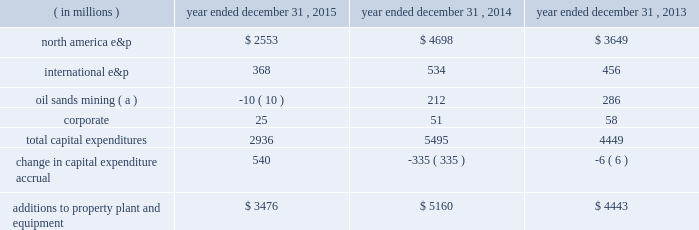Borrowings reflect net proceeds received from the issuance of senior notes in june 2015 .
See liquidity and capital resources below for additional information .
In november 2015 , we repaid our $ 1 billion 0.90% ( 0.90 % ) senior notes upon maturity .
In october 2015 , we announced an adjustment to our quarterly dividend .
See capital requirements below for additional information .
Additions to property , plant and equipment are our most significant use of cash and cash equivalents .
The table shows capital expenditures related to continuing operations by segment and reconciles to additions to property , plant and equipment as presented in the consolidated statements of cash flows for 2015 , 2014 and 2013: .
( a ) reflects reimbursements earned from the governments of canada and alberta related to funds previously expended for quest ccs capital equipment .
Quest ccs was successfully completed and commissioned in the fourth quarter of 2015 .
During 2014 , we acquired 29 million shares at a cost of $ 1 billion and in 2013 acquired 14 million shares at a cost of $ 500 million .
There were no share repurchases in 2015 .
See item 8 .
Financial statements and supplementary data 2013 note 23 to the consolidated financial statements for discussion of purchases of common stock .
Liquidity and capital resources on june 10 , 2015 , we issued $ 2 billion aggregate principal amount of unsecured senior notes which consist of the following series : 2022 $ 600 million of 2.70% ( 2.70 % ) senior notes due june 1 , 2020 2022 $ 900 million of 3.85% ( 3.85 % ) senior notes due june 1 , 2025 2022 $ 500 million of 5.20% ( 5.20 % ) senior notes due june 1 , 2045 interest on each series of senior notes is payable semi-annually beginning december 1 , 2015 .
We used the aggregate net proceeds to repay our $ 1 billion 0.90% ( 0.90 % ) senior notes on november 2 , 2015 , and the remainder for general corporate purposes .
In may 2015 , we amended our $ 2.5 billion credit facility to increase the facility size by $ 500 million to a total of $ 3.0 billion and extend the maturity date by an additional year such that the credit facility now matures in may 2020 .
The amendment additionally provides us the ability to request two one-year extensions to the maturity date and an option to increase the commitment amount by up to an additional $ 500 million , subject to the consent of any increasing lenders .
The sub-facilities for swing-line loans and letters of credit remain unchanged allowing up to an aggregate amount of $ 100 million and $ 500 million , respectively .
Fees on the unused commitment of each lender , as well as the borrowing options under the credit facility , remain unchanged .
Our main sources of liquidity are cash and cash equivalents , internally generated cash flow from operations , capital market transactions , our committed revolving credit facility and sales of non-core assets .
Our working capital requirements are supported by these sources and we may issue either commercial paper backed by our $ 3.0 billion revolving credit facility or draw on our $ 3.0 billion revolving credit facility to meet short-term cash requirements or issue debt or equity securities through the shelf registration statement discussed below as part of our longer-term liquidity and capital management .
Because of the alternatives available to us as discussed above , we believe that our short-term and long-term liquidity is adequate to fund not only our current operations , but also our near-term and long-term funding requirements including our capital spending programs , dividend payments , defined benefit plan contributions , repayment of debt maturities and other amounts that may ultimately be paid in connection with contingencies .
General economic conditions , commodity prices , and financial , business and other factors could affect our operations and our ability to access the capital markets .
A downgrade in our credit ratings could negatively impact our cost of capital and our ability to access the capital markets , increase the interest rate and fees we pay on our unsecured revolving credit facility , restrict our access to the commercial paper market , or require us to post letters of credit or other forms of collateral for certain .
During 2013 , what was the average cost per share acquired? 
Computations: (500 / 14)
Answer: 35.71429. Borrowings reflect net proceeds received from the issuance of senior notes in june 2015 .
See liquidity and capital resources below for additional information .
In november 2015 , we repaid our $ 1 billion 0.90% ( 0.90 % ) senior notes upon maturity .
In october 2015 , we announced an adjustment to our quarterly dividend .
See capital requirements below for additional information .
Additions to property , plant and equipment are our most significant use of cash and cash equivalents .
The table shows capital expenditures related to continuing operations by segment and reconciles to additions to property , plant and equipment as presented in the consolidated statements of cash flows for 2015 , 2014 and 2013: .
( a ) reflects reimbursements earned from the governments of canada and alberta related to funds previously expended for quest ccs capital equipment .
Quest ccs was successfully completed and commissioned in the fourth quarter of 2015 .
During 2014 , we acquired 29 million shares at a cost of $ 1 billion and in 2013 acquired 14 million shares at a cost of $ 500 million .
There were no share repurchases in 2015 .
See item 8 .
Financial statements and supplementary data 2013 note 23 to the consolidated financial statements for discussion of purchases of common stock .
Liquidity and capital resources on june 10 , 2015 , we issued $ 2 billion aggregate principal amount of unsecured senior notes which consist of the following series : 2022 $ 600 million of 2.70% ( 2.70 % ) senior notes due june 1 , 2020 2022 $ 900 million of 3.85% ( 3.85 % ) senior notes due june 1 , 2025 2022 $ 500 million of 5.20% ( 5.20 % ) senior notes due june 1 , 2045 interest on each series of senior notes is payable semi-annually beginning december 1 , 2015 .
We used the aggregate net proceeds to repay our $ 1 billion 0.90% ( 0.90 % ) senior notes on november 2 , 2015 , and the remainder for general corporate purposes .
In may 2015 , we amended our $ 2.5 billion credit facility to increase the facility size by $ 500 million to a total of $ 3.0 billion and extend the maturity date by an additional year such that the credit facility now matures in may 2020 .
The amendment additionally provides us the ability to request two one-year extensions to the maturity date and an option to increase the commitment amount by up to an additional $ 500 million , subject to the consent of any increasing lenders .
The sub-facilities for swing-line loans and letters of credit remain unchanged allowing up to an aggregate amount of $ 100 million and $ 500 million , respectively .
Fees on the unused commitment of each lender , as well as the borrowing options under the credit facility , remain unchanged .
Our main sources of liquidity are cash and cash equivalents , internally generated cash flow from operations , capital market transactions , our committed revolving credit facility and sales of non-core assets .
Our working capital requirements are supported by these sources and we may issue either commercial paper backed by our $ 3.0 billion revolving credit facility or draw on our $ 3.0 billion revolving credit facility to meet short-term cash requirements or issue debt or equity securities through the shelf registration statement discussed below as part of our longer-term liquidity and capital management .
Because of the alternatives available to us as discussed above , we believe that our short-term and long-term liquidity is adequate to fund not only our current operations , but also our near-term and long-term funding requirements including our capital spending programs , dividend payments , defined benefit plan contributions , repayment of debt maturities and other amounts that may ultimately be paid in connection with contingencies .
General economic conditions , commodity prices , and financial , business and other factors could affect our operations and our ability to access the capital markets .
A downgrade in our credit ratings could negatively impact our cost of capital and our ability to access the capital markets , increase the interest rate and fees we pay on our unsecured revolving credit facility , restrict our access to the commercial paper market , or require us to post letters of credit or other forms of collateral for certain .
By how much did additions to property plant and equipment decrease from 2013 to 2015? 
Computations: ((3476 - 4443) / 4443)
Answer: -0.21765. 